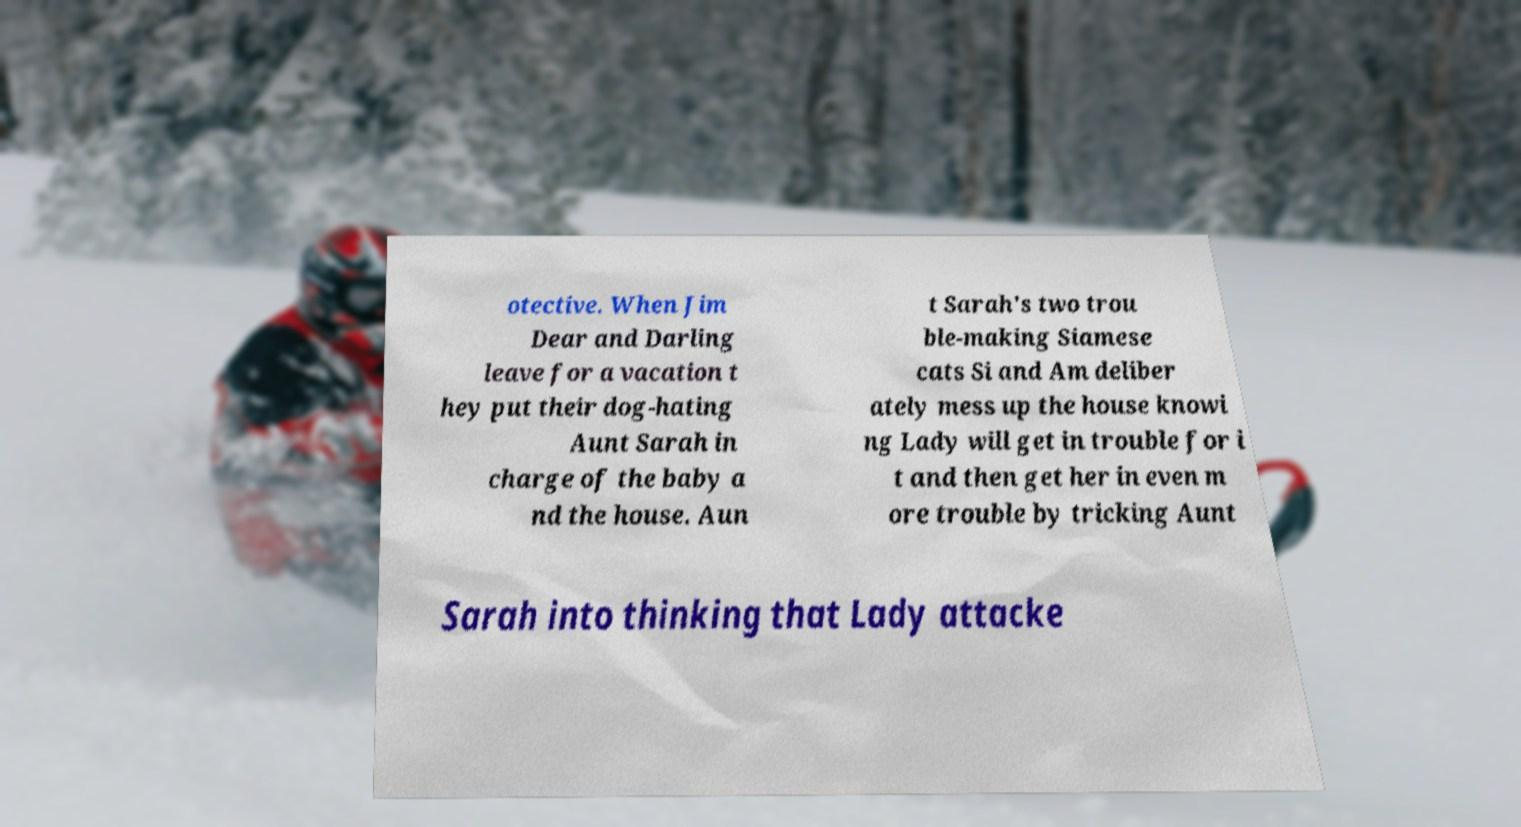Could you assist in decoding the text presented in this image and type it out clearly? otective. When Jim Dear and Darling leave for a vacation t hey put their dog-hating Aunt Sarah in charge of the baby a nd the house. Aun t Sarah's two trou ble-making Siamese cats Si and Am deliber ately mess up the house knowi ng Lady will get in trouble for i t and then get her in even m ore trouble by tricking Aunt Sarah into thinking that Lady attacke 